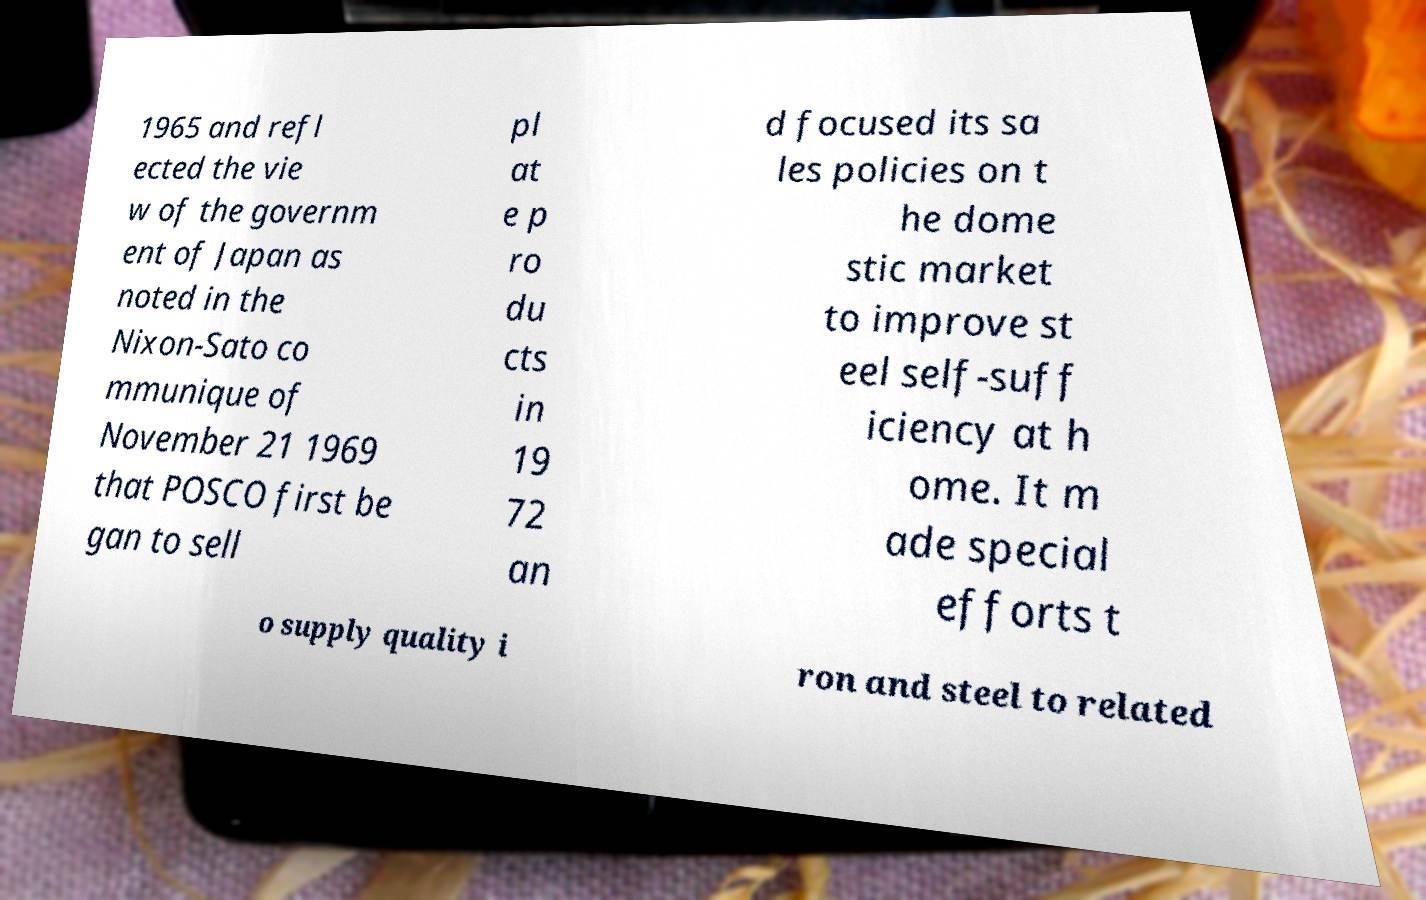Could you extract and type out the text from this image? 1965 and refl ected the vie w of the governm ent of Japan as noted in the Nixon-Sato co mmunique of November 21 1969 that POSCO first be gan to sell pl at e p ro du cts in 19 72 an d focused its sa les policies on t he dome stic market to improve st eel self-suff iciency at h ome. It m ade special efforts t o supply quality i ron and steel to related 